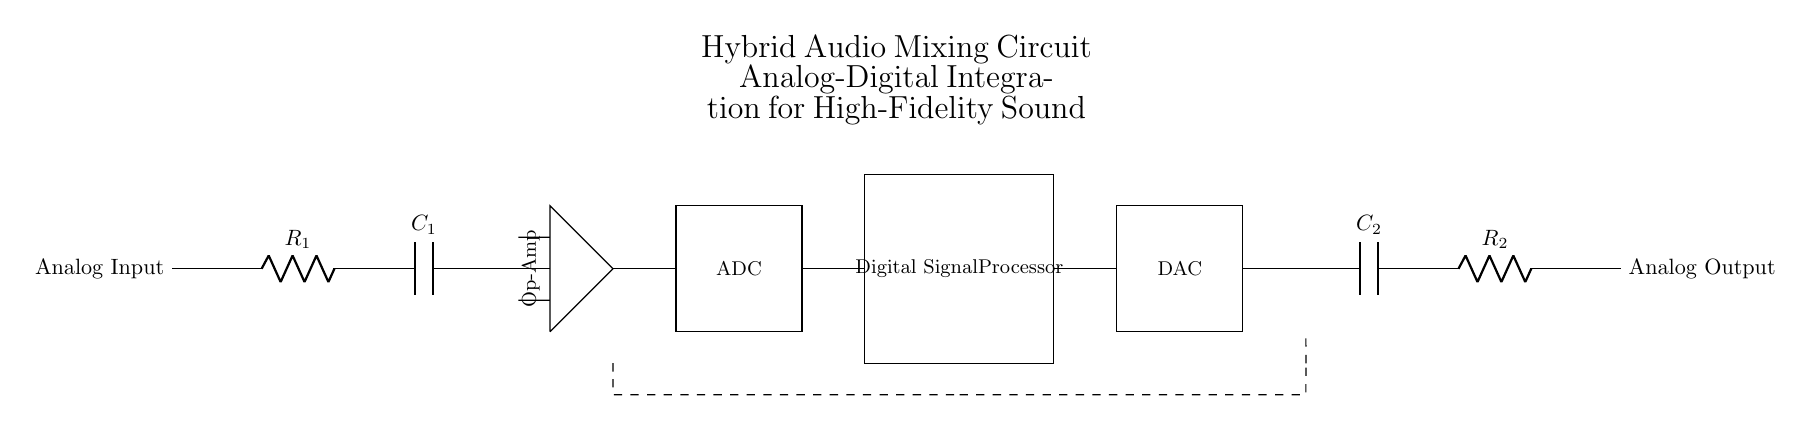What is the primary function of the op-amp in this circuit? The op-amp amplifies the analog signal coming from the input stage. Its role is to strengthen the signal before it undergoes analog-to-digital conversion.
Answer: Amplification What are the components used in the output stage? The output stage includes a capacitor and a resistor, which help in filtering and shaping the final analog output signal.
Answer: Capacitor and resistor How many digital components are present in this circuit? The schematic shows two digital components: the ADC (Analog-to-Digital Converter) and the Digital Signal Processor (DSP).
Answer: Two What is the purpose of the feedback loop in this circuit? The feedback loop provides a path for the output of the system to influence the input, which helps in stabilizing the gain and improving sound quality.
Answer: Stabilization What is the type of signal processed by the DAC? The DAC processes a digital signal and converts it back into an analog format suitable for output.
Answer: Digital How does the analog signal enter the circuit? The analog signal enters through the initial input labeled as "Analog Input," which connects to the first resistor in the series.
Answer: Analog Input 